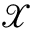Convert formula to latex. <formula><loc_0><loc_0><loc_500><loc_500>\mathcal { X }</formula> 